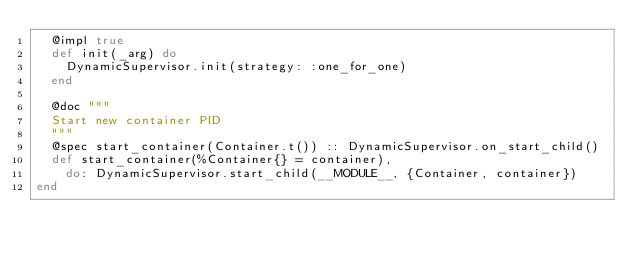Convert code to text. <code><loc_0><loc_0><loc_500><loc_500><_Elixir_>  @impl true
  def init(_arg) do
    DynamicSupervisor.init(strategy: :one_for_one)
  end

  @doc """
  Start new container PID
  """
  @spec start_container(Container.t()) :: DynamicSupervisor.on_start_child()
  def start_container(%Container{} = container),
    do: DynamicSupervisor.start_child(__MODULE__, {Container, container})
end
</code> 